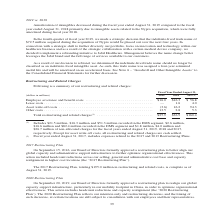According to Jabil Circuit's financial document, How much was of total restructuring and related charges was recorded in the EMS segment in 2019? According to the financial document, $21.5 million. The relevant text states: "(1) Includes $21.5 million, $16.3 million and $51.3 million recorded in the EMS segment, $2.6 million, $16.6 million and $82.4..." Also, What were the Employee severance and benefit costs in 2018? According to the financial document, $16.3 (in millions). The relevant text states: "Employee severance and benefit costs . $16.0 $16.3 $ 56.8 Lease costs . — 1.6 4.0 Asset write-off costs . (3.6) 16.2 94.3 Other costs . 13.5 2.8 5.3..." Also, Which years of Restructuring Plans did the fiscal year ended August 31, 2017 include expenses related to? The document shows two values: 2017 and 2013. From the document: "(dollars in millions) 2019 2018 2017 (2) (dollars in millions) 2019 2018 2017 (2) , 2017, includes expenses related to the 2017 and 2013 Restructuring..." Also, can you calculate: What was the change in Employee severance and benefit costs between 2018 and 2019? Based on the calculation: $16.0-$16.3, the result is -0.3 (in millions). This is based on the information: "Employee severance and benefit costs . $16.0 $16.3 $ 56.8 Lease costs . — 1.6 4.0 Asset write-off costs . (3.6) 16.2 94.3 Other costs . 13.5 2.8 5.3 Employee severance and benefit costs . $16.0 $16.3 ..." The key data points involved are: 16.0, 16.3. Also, How many years did Total restructuring and related charges exceed $100 million? Based on the analysis, there are 1 instances. The counting process: 2017. Also, can you calculate: What was the percentage change in other costs between 2018 and 2019? To answer this question, I need to perform calculations using the financial data. The calculation is: (13.5-2.8)/2.8, which equals 382.14 (percentage). This is based on the information: "te-off costs . (3.6) 16.2 94.3 Other costs . 13.5 2.8 5.3 t write-off costs . (3.6) 16.2 94.3 Other costs . 13.5 2.8 5.3..." The key data points involved are: 13.5, 2.8. 